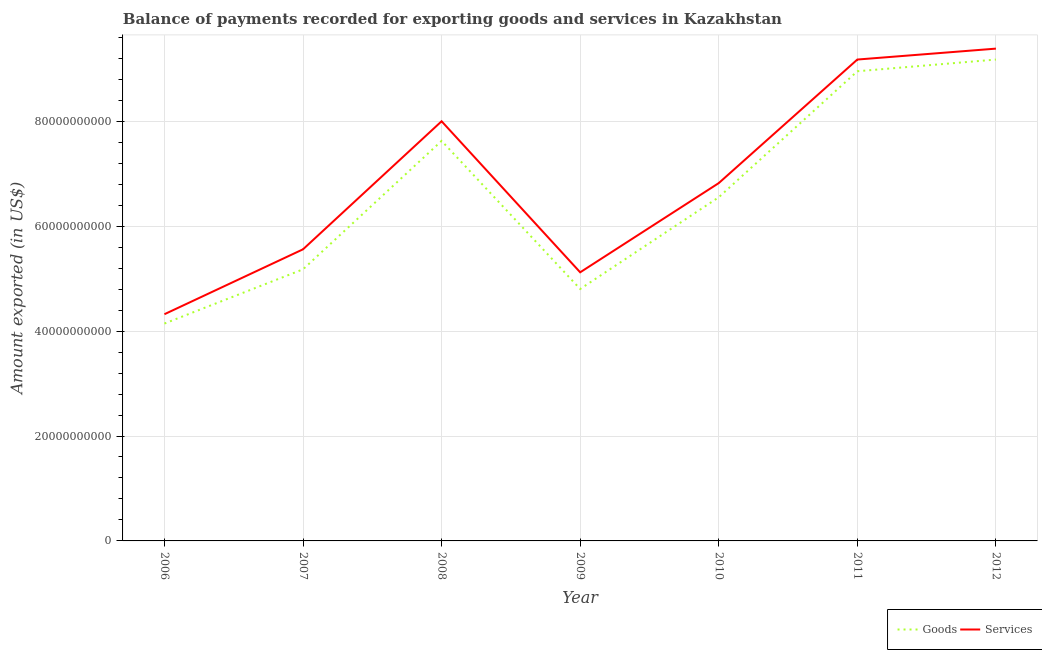Is the number of lines equal to the number of legend labels?
Your answer should be compact. Yes. What is the amount of goods exported in 2007?
Your answer should be very brief. 5.18e+1. Across all years, what is the maximum amount of services exported?
Offer a very short reply. 9.38e+1. Across all years, what is the minimum amount of goods exported?
Your answer should be compact. 4.14e+1. In which year was the amount of services exported maximum?
Your answer should be very brief. 2012. What is the total amount of goods exported in the graph?
Your response must be concise. 4.64e+11. What is the difference between the amount of goods exported in 2009 and that in 2011?
Provide a short and direct response. -4.15e+1. What is the difference between the amount of goods exported in 2006 and the amount of services exported in 2008?
Provide a short and direct response. -3.86e+1. What is the average amount of services exported per year?
Your answer should be very brief. 6.91e+1. In the year 2008, what is the difference between the amount of goods exported and amount of services exported?
Make the answer very short. -3.74e+09. In how many years, is the amount of goods exported greater than 76000000000 US$?
Your answer should be very brief. 3. What is the ratio of the amount of goods exported in 2010 to that in 2012?
Offer a terse response. 0.71. Is the amount of goods exported in 2007 less than that in 2010?
Provide a succinct answer. Yes. What is the difference between the highest and the second highest amount of services exported?
Offer a very short reply. 2.08e+09. What is the difference between the highest and the lowest amount of goods exported?
Make the answer very short. 5.03e+1. Is the sum of the amount of services exported in 2010 and 2011 greater than the maximum amount of goods exported across all years?
Ensure brevity in your answer.  Yes. Is the amount of goods exported strictly less than the amount of services exported over the years?
Make the answer very short. Yes. What is the difference between two consecutive major ticks on the Y-axis?
Make the answer very short. 2.00e+1. Are the values on the major ticks of Y-axis written in scientific E-notation?
Provide a short and direct response. No. Does the graph contain any zero values?
Make the answer very short. No. Does the graph contain grids?
Provide a succinct answer. Yes. Where does the legend appear in the graph?
Your response must be concise. Bottom right. How are the legend labels stacked?
Ensure brevity in your answer.  Horizontal. What is the title of the graph?
Provide a succinct answer. Balance of payments recorded for exporting goods and services in Kazakhstan. Does "Commercial service imports" appear as one of the legend labels in the graph?
Your response must be concise. No. What is the label or title of the X-axis?
Your answer should be compact. Year. What is the label or title of the Y-axis?
Offer a terse response. Amount exported (in US$). What is the Amount exported (in US$) in Goods in 2006?
Your answer should be very brief. 4.14e+1. What is the Amount exported (in US$) in Services in 2006?
Offer a very short reply. 4.32e+1. What is the Amount exported (in US$) in Goods in 2007?
Offer a terse response. 5.18e+1. What is the Amount exported (in US$) in Services in 2007?
Provide a short and direct response. 5.56e+1. What is the Amount exported (in US$) of Goods in 2008?
Provide a short and direct response. 7.63e+1. What is the Amount exported (in US$) in Services in 2008?
Keep it short and to the point. 8.00e+1. What is the Amount exported (in US$) of Goods in 2009?
Ensure brevity in your answer.  4.80e+1. What is the Amount exported (in US$) of Services in 2009?
Provide a short and direct response. 5.12e+1. What is the Amount exported (in US$) of Goods in 2010?
Keep it short and to the point. 6.55e+1. What is the Amount exported (in US$) in Services in 2010?
Ensure brevity in your answer.  6.82e+1. What is the Amount exported (in US$) in Goods in 2011?
Your answer should be very brief. 8.95e+1. What is the Amount exported (in US$) in Services in 2011?
Your answer should be compact. 9.18e+1. What is the Amount exported (in US$) of Goods in 2012?
Keep it short and to the point. 9.18e+1. What is the Amount exported (in US$) in Services in 2012?
Your answer should be compact. 9.38e+1. Across all years, what is the maximum Amount exported (in US$) of Goods?
Your response must be concise. 9.18e+1. Across all years, what is the maximum Amount exported (in US$) in Services?
Offer a very short reply. 9.38e+1. Across all years, what is the minimum Amount exported (in US$) of Goods?
Provide a short and direct response. 4.14e+1. Across all years, what is the minimum Amount exported (in US$) of Services?
Your answer should be compact. 4.32e+1. What is the total Amount exported (in US$) in Goods in the graph?
Your answer should be compact. 4.64e+11. What is the total Amount exported (in US$) in Services in the graph?
Ensure brevity in your answer.  4.84e+11. What is the difference between the Amount exported (in US$) in Goods in 2006 and that in 2007?
Your response must be concise. -1.03e+1. What is the difference between the Amount exported (in US$) of Services in 2006 and that in 2007?
Make the answer very short. -1.24e+1. What is the difference between the Amount exported (in US$) of Goods in 2006 and that in 2008?
Your answer should be very brief. -3.48e+1. What is the difference between the Amount exported (in US$) in Services in 2006 and that in 2008?
Your answer should be very brief. -3.68e+1. What is the difference between the Amount exported (in US$) of Goods in 2006 and that in 2009?
Your response must be concise. -6.59e+09. What is the difference between the Amount exported (in US$) in Services in 2006 and that in 2009?
Provide a short and direct response. -7.99e+09. What is the difference between the Amount exported (in US$) in Goods in 2006 and that in 2010?
Give a very brief answer. -2.41e+1. What is the difference between the Amount exported (in US$) in Services in 2006 and that in 2010?
Your answer should be compact. -2.50e+1. What is the difference between the Amount exported (in US$) in Goods in 2006 and that in 2011?
Your answer should be very brief. -4.81e+1. What is the difference between the Amount exported (in US$) in Services in 2006 and that in 2011?
Your response must be concise. -4.85e+1. What is the difference between the Amount exported (in US$) in Goods in 2006 and that in 2012?
Your answer should be compact. -5.03e+1. What is the difference between the Amount exported (in US$) of Services in 2006 and that in 2012?
Offer a terse response. -5.06e+1. What is the difference between the Amount exported (in US$) of Goods in 2007 and that in 2008?
Your answer should be very brief. -2.45e+1. What is the difference between the Amount exported (in US$) in Services in 2007 and that in 2008?
Give a very brief answer. -2.44e+1. What is the difference between the Amount exported (in US$) in Goods in 2007 and that in 2009?
Ensure brevity in your answer.  3.75e+09. What is the difference between the Amount exported (in US$) of Services in 2007 and that in 2009?
Make the answer very short. 4.38e+09. What is the difference between the Amount exported (in US$) in Goods in 2007 and that in 2010?
Provide a succinct answer. -1.37e+1. What is the difference between the Amount exported (in US$) of Services in 2007 and that in 2010?
Give a very brief answer. -1.26e+1. What is the difference between the Amount exported (in US$) in Goods in 2007 and that in 2011?
Your response must be concise. -3.78e+1. What is the difference between the Amount exported (in US$) in Services in 2007 and that in 2011?
Offer a terse response. -3.62e+1. What is the difference between the Amount exported (in US$) of Goods in 2007 and that in 2012?
Give a very brief answer. -4.00e+1. What is the difference between the Amount exported (in US$) in Services in 2007 and that in 2012?
Make the answer very short. -3.83e+1. What is the difference between the Amount exported (in US$) in Goods in 2008 and that in 2009?
Ensure brevity in your answer.  2.82e+1. What is the difference between the Amount exported (in US$) in Services in 2008 and that in 2009?
Make the answer very short. 2.88e+1. What is the difference between the Amount exported (in US$) of Goods in 2008 and that in 2010?
Your response must be concise. 1.07e+1. What is the difference between the Amount exported (in US$) in Services in 2008 and that in 2010?
Keep it short and to the point. 1.18e+1. What is the difference between the Amount exported (in US$) of Goods in 2008 and that in 2011?
Give a very brief answer. -1.33e+1. What is the difference between the Amount exported (in US$) of Services in 2008 and that in 2011?
Give a very brief answer. -1.18e+1. What is the difference between the Amount exported (in US$) of Goods in 2008 and that in 2012?
Offer a terse response. -1.55e+1. What is the difference between the Amount exported (in US$) in Services in 2008 and that in 2012?
Offer a terse response. -1.38e+1. What is the difference between the Amount exported (in US$) in Goods in 2009 and that in 2010?
Your answer should be compact. -1.75e+1. What is the difference between the Amount exported (in US$) of Services in 2009 and that in 2010?
Your response must be concise. -1.70e+1. What is the difference between the Amount exported (in US$) of Goods in 2009 and that in 2011?
Your response must be concise. -4.15e+1. What is the difference between the Amount exported (in US$) of Services in 2009 and that in 2011?
Give a very brief answer. -4.06e+1. What is the difference between the Amount exported (in US$) of Goods in 2009 and that in 2012?
Provide a succinct answer. -4.37e+1. What is the difference between the Amount exported (in US$) in Services in 2009 and that in 2012?
Make the answer very short. -4.26e+1. What is the difference between the Amount exported (in US$) of Goods in 2010 and that in 2011?
Provide a short and direct response. -2.40e+1. What is the difference between the Amount exported (in US$) in Services in 2010 and that in 2011?
Your response must be concise. -2.36e+1. What is the difference between the Amount exported (in US$) in Goods in 2010 and that in 2012?
Keep it short and to the point. -2.62e+1. What is the difference between the Amount exported (in US$) in Services in 2010 and that in 2012?
Offer a terse response. -2.56e+1. What is the difference between the Amount exported (in US$) of Goods in 2011 and that in 2012?
Ensure brevity in your answer.  -2.23e+09. What is the difference between the Amount exported (in US$) in Services in 2011 and that in 2012?
Your answer should be compact. -2.08e+09. What is the difference between the Amount exported (in US$) in Goods in 2006 and the Amount exported (in US$) in Services in 2007?
Provide a short and direct response. -1.41e+1. What is the difference between the Amount exported (in US$) of Goods in 2006 and the Amount exported (in US$) of Services in 2008?
Provide a succinct answer. -3.86e+1. What is the difference between the Amount exported (in US$) of Goods in 2006 and the Amount exported (in US$) of Services in 2009?
Your answer should be very brief. -9.77e+09. What is the difference between the Amount exported (in US$) of Goods in 2006 and the Amount exported (in US$) of Services in 2010?
Provide a succinct answer. -2.68e+1. What is the difference between the Amount exported (in US$) of Goods in 2006 and the Amount exported (in US$) of Services in 2011?
Offer a terse response. -5.03e+1. What is the difference between the Amount exported (in US$) of Goods in 2006 and the Amount exported (in US$) of Services in 2012?
Your answer should be compact. -5.24e+1. What is the difference between the Amount exported (in US$) in Goods in 2007 and the Amount exported (in US$) in Services in 2008?
Keep it short and to the point. -2.82e+1. What is the difference between the Amount exported (in US$) of Goods in 2007 and the Amount exported (in US$) of Services in 2009?
Your answer should be very brief. 5.68e+08. What is the difference between the Amount exported (in US$) of Goods in 2007 and the Amount exported (in US$) of Services in 2010?
Your answer should be very brief. -1.64e+1. What is the difference between the Amount exported (in US$) of Goods in 2007 and the Amount exported (in US$) of Services in 2011?
Keep it short and to the point. -4.00e+1. What is the difference between the Amount exported (in US$) of Goods in 2007 and the Amount exported (in US$) of Services in 2012?
Provide a short and direct response. -4.21e+1. What is the difference between the Amount exported (in US$) in Goods in 2008 and the Amount exported (in US$) in Services in 2009?
Provide a succinct answer. 2.51e+1. What is the difference between the Amount exported (in US$) of Goods in 2008 and the Amount exported (in US$) of Services in 2010?
Offer a terse response. 8.04e+09. What is the difference between the Amount exported (in US$) in Goods in 2008 and the Amount exported (in US$) in Services in 2011?
Give a very brief answer. -1.55e+1. What is the difference between the Amount exported (in US$) in Goods in 2008 and the Amount exported (in US$) in Services in 2012?
Offer a terse response. -1.76e+1. What is the difference between the Amount exported (in US$) of Goods in 2009 and the Amount exported (in US$) of Services in 2010?
Ensure brevity in your answer.  -2.02e+1. What is the difference between the Amount exported (in US$) of Goods in 2009 and the Amount exported (in US$) of Services in 2011?
Your answer should be compact. -4.37e+1. What is the difference between the Amount exported (in US$) of Goods in 2009 and the Amount exported (in US$) of Services in 2012?
Your answer should be very brief. -4.58e+1. What is the difference between the Amount exported (in US$) of Goods in 2010 and the Amount exported (in US$) of Services in 2011?
Your response must be concise. -2.63e+1. What is the difference between the Amount exported (in US$) of Goods in 2010 and the Amount exported (in US$) of Services in 2012?
Keep it short and to the point. -2.83e+1. What is the difference between the Amount exported (in US$) in Goods in 2011 and the Amount exported (in US$) in Services in 2012?
Your response must be concise. -4.31e+09. What is the average Amount exported (in US$) of Goods per year?
Ensure brevity in your answer.  6.63e+1. What is the average Amount exported (in US$) of Services per year?
Ensure brevity in your answer.  6.91e+1. In the year 2006, what is the difference between the Amount exported (in US$) in Goods and Amount exported (in US$) in Services?
Your answer should be compact. -1.78e+09. In the year 2007, what is the difference between the Amount exported (in US$) in Goods and Amount exported (in US$) in Services?
Ensure brevity in your answer.  -3.82e+09. In the year 2008, what is the difference between the Amount exported (in US$) in Goods and Amount exported (in US$) in Services?
Ensure brevity in your answer.  -3.74e+09. In the year 2009, what is the difference between the Amount exported (in US$) in Goods and Amount exported (in US$) in Services?
Make the answer very short. -3.18e+09. In the year 2010, what is the difference between the Amount exported (in US$) of Goods and Amount exported (in US$) of Services?
Offer a very short reply. -2.70e+09. In the year 2011, what is the difference between the Amount exported (in US$) in Goods and Amount exported (in US$) in Services?
Offer a terse response. -2.23e+09. In the year 2012, what is the difference between the Amount exported (in US$) in Goods and Amount exported (in US$) in Services?
Provide a short and direct response. -2.09e+09. What is the ratio of the Amount exported (in US$) of Goods in 2006 to that in 2007?
Keep it short and to the point. 0.8. What is the ratio of the Amount exported (in US$) in Services in 2006 to that in 2007?
Offer a very short reply. 0.78. What is the ratio of the Amount exported (in US$) of Goods in 2006 to that in 2008?
Ensure brevity in your answer.  0.54. What is the ratio of the Amount exported (in US$) in Services in 2006 to that in 2008?
Your answer should be very brief. 0.54. What is the ratio of the Amount exported (in US$) of Goods in 2006 to that in 2009?
Keep it short and to the point. 0.86. What is the ratio of the Amount exported (in US$) of Services in 2006 to that in 2009?
Provide a short and direct response. 0.84. What is the ratio of the Amount exported (in US$) of Goods in 2006 to that in 2010?
Your response must be concise. 0.63. What is the ratio of the Amount exported (in US$) in Services in 2006 to that in 2010?
Keep it short and to the point. 0.63. What is the ratio of the Amount exported (in US$) of Goods in 2006 to that in 2011?
Your answer should be very brief. 0.46. What is the ratio of the Amount exported (in US$) of Services in 2006 to that in 2011?
Provide a short and direct response. 0.47. What is the ratio of the Amount exported (in US$) in Goods in 2006 to that in 2012?
Keep it short and to the point. 0.45. What is the ratio of the Amount exported (in US$) in Services in 2006 to that in 2012?
Provide a succinct answer. 0.46. What is the ratio of the Amount exported (in US$) of Goods in 2007 to that in 2008?
Make the answer very short. 0.68. What is the ratio of the Amount exported (in US$) of Services in 2007 to that in 2008?
Provide a succinct answer. 0.69. What is the ratio of the Amount exported (in US$) of Goods in 2007 to that in 2009?
Your answer should be very brief. 1.08. What is the ratio of the Amount exported (in US$) of Services in 2007 to that in 2009?
Your response must be concise. 1.09. What is the ratio of the Amount exported (in US$) of Goods in 2007 to that in 2010?
Provide a short and direct response. 0.79. What is the ratio of the Amount exported (in US$) of Services in 2007 to that in 2010?
Make the answer very short. 0.81. What is the ratio of the Amount exported (in US$) of Goods in 2007 to that in 2011?
Give a very brief answer. 0.58. What is the ratio of the Amount exported (in US$) in Services in 2007 to that in 2011?
Your response must be concise. 0.61. What is the ratio of the Amount exported (in US$) of Goods in 2007 to that in 2012?
Your response must be concise. 0.56. What is the ratio of the Amount exported (in US$) of Services in 2007 to that in 2012?
Make the answer very short. 0.59. What is the ratio of the Amount exported (in US$) in Goods in 2008 to that in 2009?
Your answer should be compact. 1.59. What is the ratio of the Amount exported (in US$) of Services in 2008 to that in 2009?
Keep it short and to the point. 1.56. What is the ratio of the Amount exported (in US$) in Goods in 2008 to that in 2010?
Your answer should be compact. 1.16. What is the ratio of the Amount exported (in US$) in Services in 2008 to that in 2010?
Your answer should be compact. 1.17. What is the ratio of the Amount exported (in US$) in Goods in 2008 to that in 2011?
Your response must be concise. 0.85. What is the ratio of the Amount exported (in US$) of Services in 2008 to that in 2011?
Provide a short and direct response. 0.87. What is the ratio of the Amount exported (in US$) of Goods in 2008 to that in 2012?
Your response must be concise. 0.83. What is the ratio of the Amount exported (in US$) of Services in 2008 to that in 2012?
Your response must be concise. 0.85. What is the ratio of the Amount exported (in US$) in Goods in 2009 to that in 2010?
Ensure brevity in your answer.  0.73. What is the ratio of the Amount exported (in US$) of Services in 2009 to that in 2010?
Keep it short and to the point. 0.75. What is the ratio of the Amount exported (in US$) of Goods in 2009 to that in 2011?
Provide a succinct answer. 0.54. What is the ratio of the Amount exported (in US$) in Services in 2009 to that in 2011?
Your answer should be compact. 0.56. What is the ratio of the Amount exported (in US$) of Goods in 2009 to that in 2012?
Your response must be concise. 0.52. What is the ratio of the Amount exported (in US$) of Services in 2009 to that in 2012?
Ensure brevity in your answer.  0.55. What is the ratio of the Amount exported (in US$) in Goods in 2010 to that in 2011?
Offer a very short reply. 0.73. What is the ratio of the Amount exported (in US$) in Services in 2010 to that in 2011?
Offer a very short reply. 0.74. What is the ratio of the Amount exported (in US$) of Goods in 2010 to that in 2012?
Offer a terse response. 0.71. What is the ratio of the Amount exported (in US$) in Services in 2010 to that in 2012?
Keep it short and to the point. 0.73. What is the ratio of the Amount exported (in US$) of Goods in 2011 to that in 2012?
Your response must be concise. 0.98. What is the ratio of the Amount exported (in US$) in Services in 2011 to that in 2012?
Provide a short and direct response. 0.98. What is the difference between the highest and the second highest Amount exported (in US$) in Goods?
Keep it short and to the point. 2.23e+09. What is the difference between the highest and the second highest Amount exported (in US$) of Services?
Your answer should be compact. 2.08e+09. What is the difference between the highest and the lowest Amount exported (in US$) in Goods?
Provide a short and direct response. 5.03e+1. What is the difference between the highest and the lowest Amount exported (in US$) of Services?
Keep it short and to the point. 5.06e+1. 